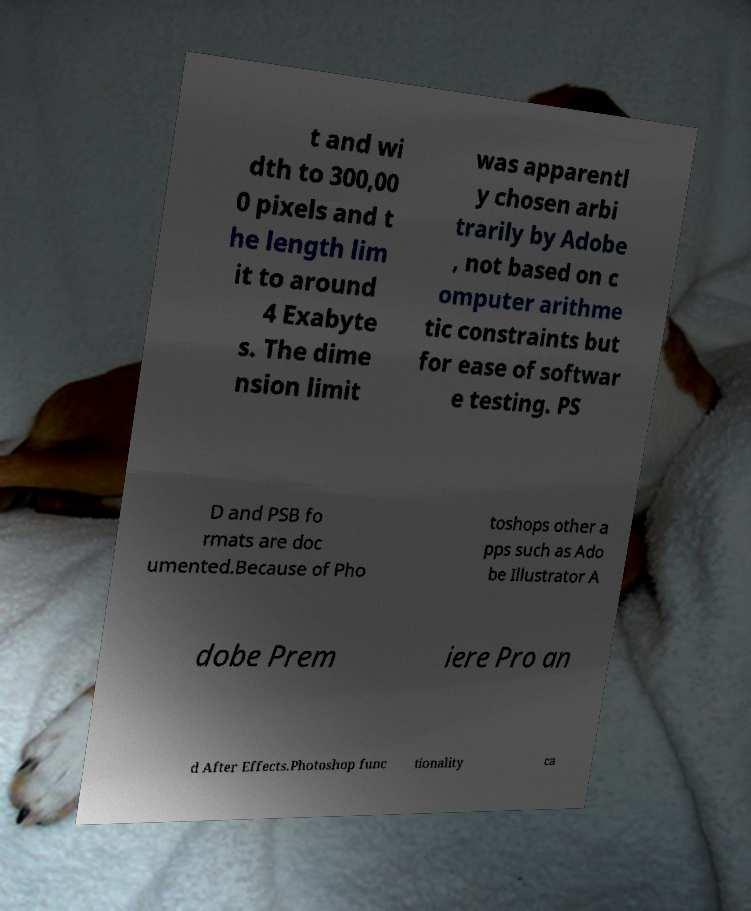There's text embedded in this image that I need extracted. Can you transcribe it verbatim? t and wi dth to 300,00 0 pixels and t he length lim it to around 4 Exabyte s. The dime nsion limit was apparentl y chosen arbi trarily by Adobe , not based on c omputer arithme tic constraints but for ease of softwar e testing. PS D and PSB fo rmats are doc umented.Because of Pho toshops other a pps such as Ado be Illustrator A dobe Prem iere Pro an d After Effects.Photoshop func tionality ca 